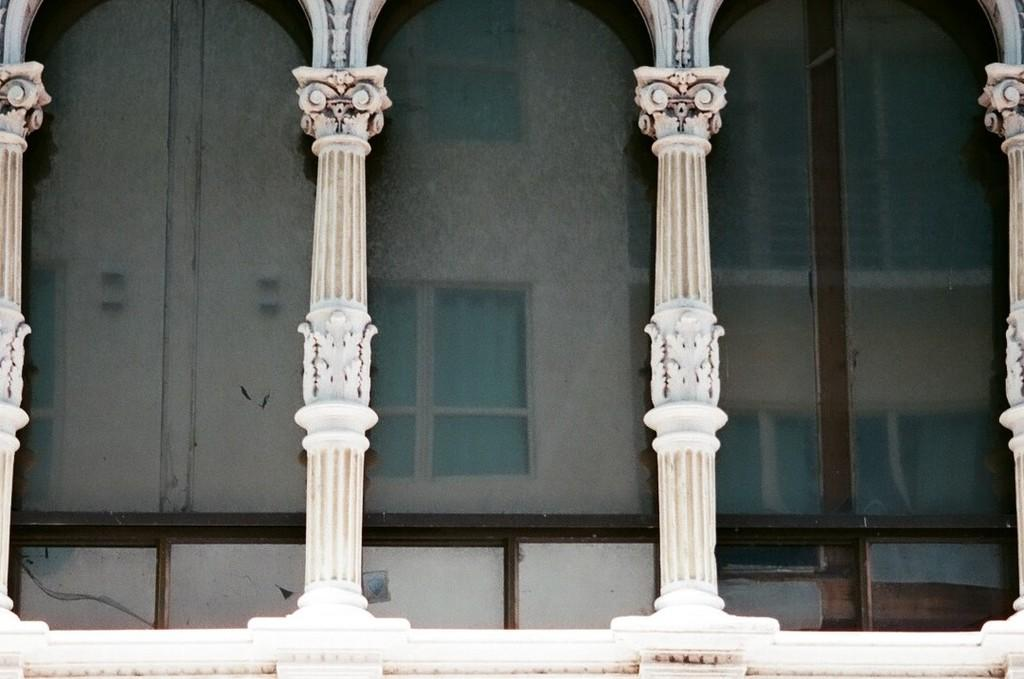What type of structure is visible in the image? There is a building in the image. What are some features of the building? The building has windows and pillars. How does the wind affect the egg on top of the building in the image? There is no egg present on top of the building in the image. 